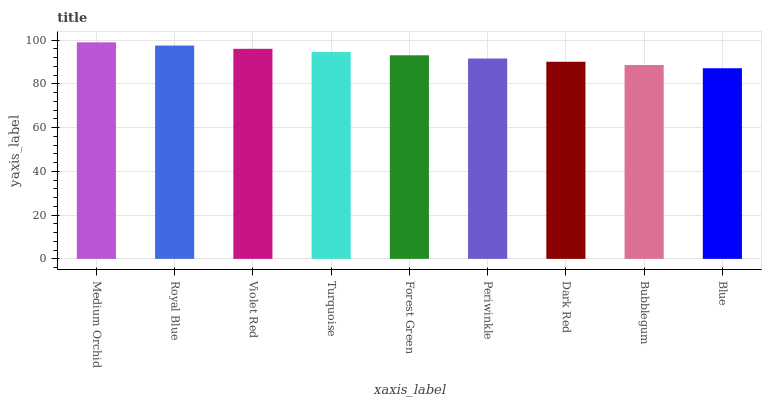Is Blue the minimum?
Answer yes or no. Yes. Is Medium Orchid the maximum?
Answer yes or no. Yes. Is Royal Blue the minimum?
Answer yes or no. No. Is Royal Blue the maximum?
Answer yes or no. No. Is Medium Orchid greater than Royal Blue?
Answer yes or no. Yes. Is Royal Blue less than Medium Orchid?
Answer yes or no. Yes. Is Royal Blue greater than Medium Orchid?
Answer yes or no. No. Is Medium Orchid less than Royal Blue?
Answer yes or no. No. Is Forest Green the high median?
Answer yes or no. Yes. Is Forest Green the low median?
Answer yes or no. Yes. Is Royal Blue the high median?
Answer yes or no. No. Is Bubblegum the low median?
Answer yes or no. No. 